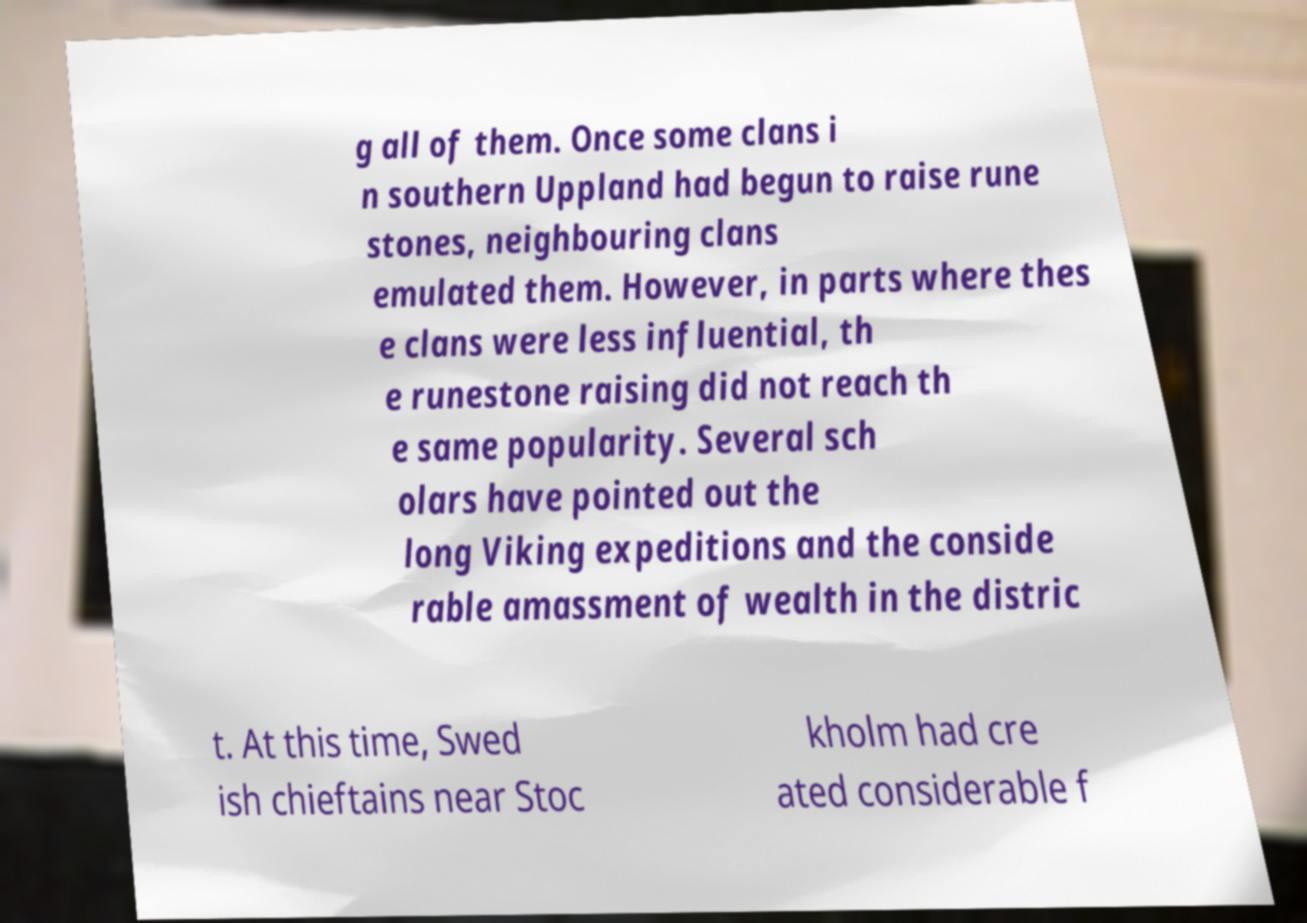Could you assist in decoding the text presented in this image and type it out clearly? g all of them. Once some clans i n southern Uppland had begun to raise rune stones, neighbouring clans emulated them. However, in parts where thes e clans were less influential, th e runestone raising did not reach th e same popularity. Several sch olars have pointed out the long Viking expeditions and the conside rable amassment of wealth in the distric t. At this time, Swed ish chieftains near Stoc kholm had cre ated considerable f 